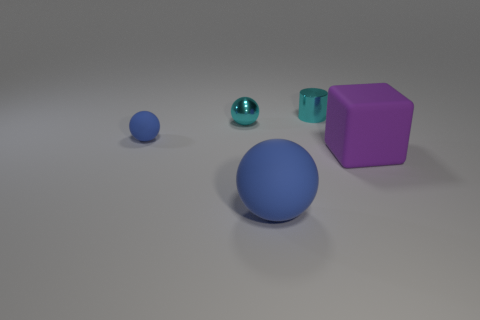What is the ball that is right of the tiny blue matte sphere and in front of the small metal sphere made of?
Give a very brief answer. Rubber. Is the big thing that is to the right of the large blue rubber sphere made of the same material as the tiny blue sphere?
Provide a short and direct response. Yes. What material is the small blue sphere?
Your answer should be very brief. Rubber. There is a rubber thing behind the purple thing; how big is it?
Your response must be concise. Small. Are there any other things of the same color as the cylinder?
Offer a very short reply. Yes. Are there any cylinders that are on the left side of the blue sphere on the left side of the cyan metal object on the left side of the large ball?
Your answer should be very brief. No. There is a tiny ball that is on the right side of the tiny blue object; is it the same color as the rubber cube?
Provide a succinct answer. No. How many cylinders are either tiny cyan objects or small matte objects?
Your answer should be compact. 1. There is a big thing that is behind the blue rubber thing in front of the tiny blue matte thing; what shape is it?
Provide a short and direct response. Cube. There is a cyan metallic thing to the right of the small metal thing that is to the left of the small cyan metal object right of the big blue object; what size is it?
Your response must be concise. Small. 